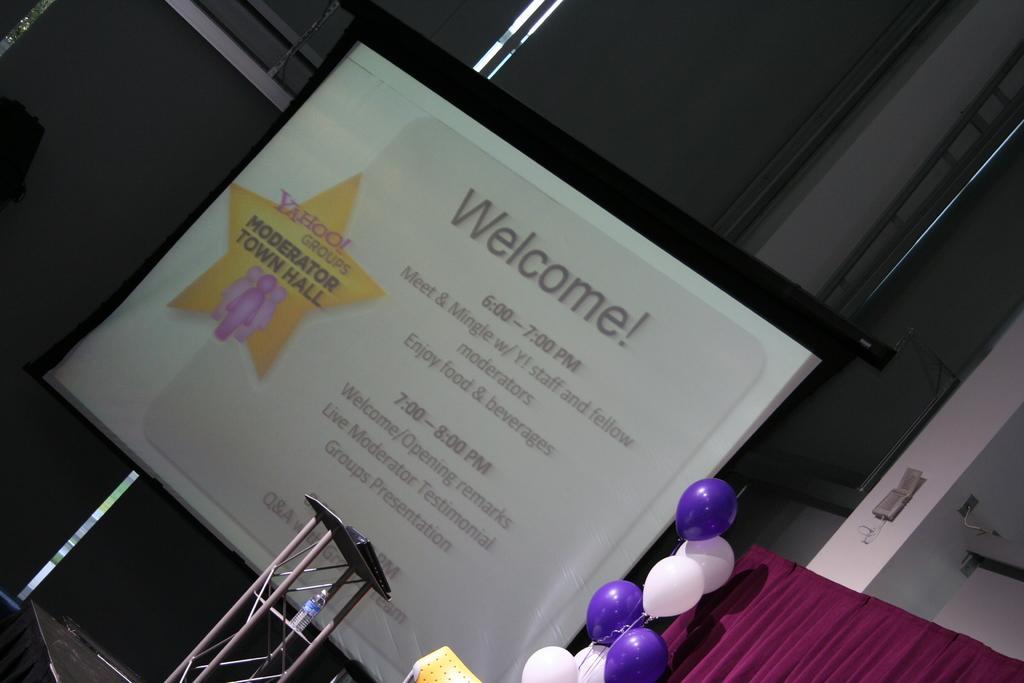In one or two sentences, can you explain what this image depicts? In this image, in the right corner, we can see a curtain which is red in color. On the right side, we can see a pillar. On the right side, we can also see some balloons. In the middle of the image, we can see a table, on the table, we can see some electronic gadgets. In the background, we can see a screen, on the screen, we can see some pictures and text written on it. In the background, we can see a wall. 